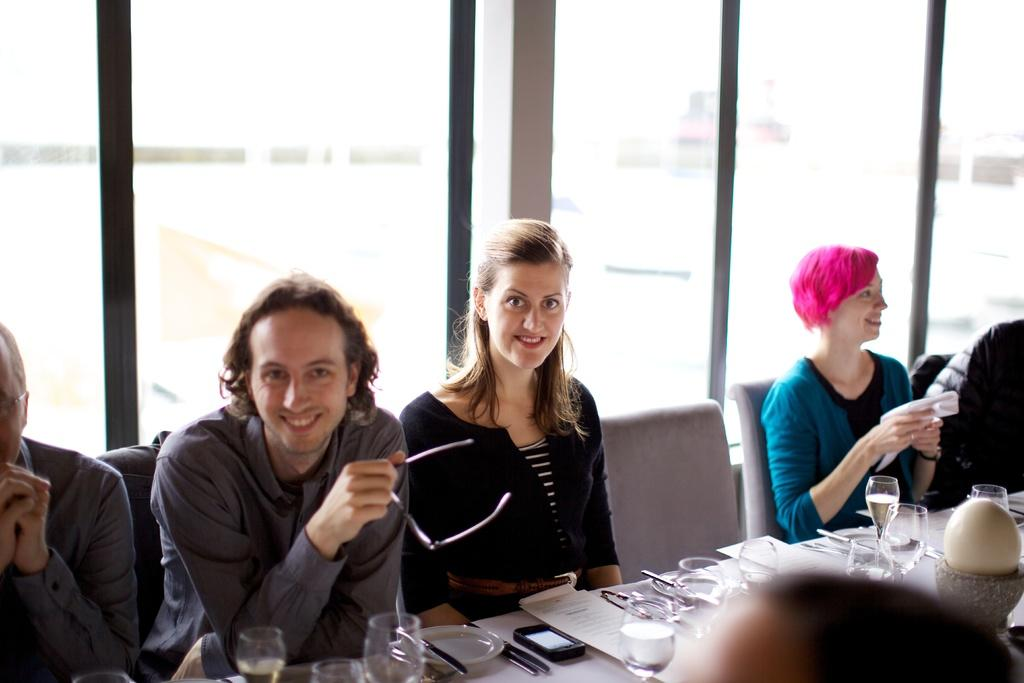How many people are in the image? There is a group of people in the image. What are the people doing in the image? The people are seated on chairs. What objects can be seen on the table in the image? There are glasses, papers, plates, and a mobile on the table. What type of tail can be seen on the people in the image? There are no tails visible on the people in the image. What is the purpose of the sink in the image? There is no sink present in the image. 